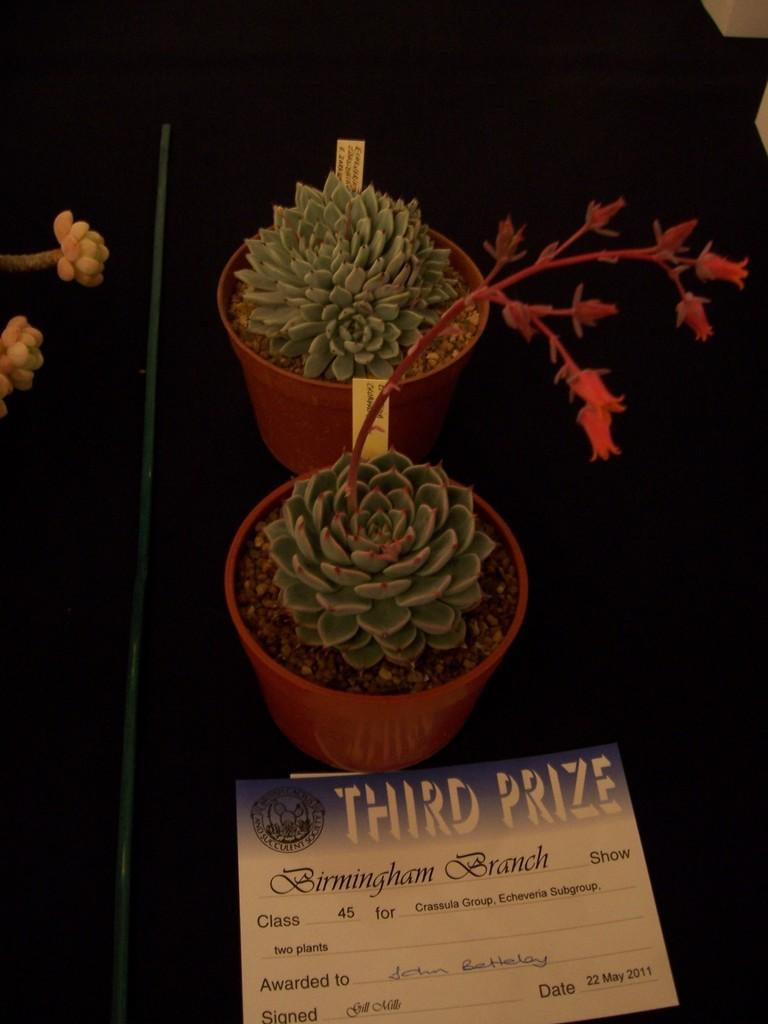What type of plants are in the image? There are potted plants in the image. What else can be seen in the image besides the plants? There is a pole and a poster with text in the image. What is the color of the background in the image? The background of the image is dark. What type of feast is being prepared in the image? There is no indication of a feast or any food preparation in the image. Can you describe the locket that is hanging from the pole in the image? There is no locket present in the image; only a pole and a poster with text are visible. 